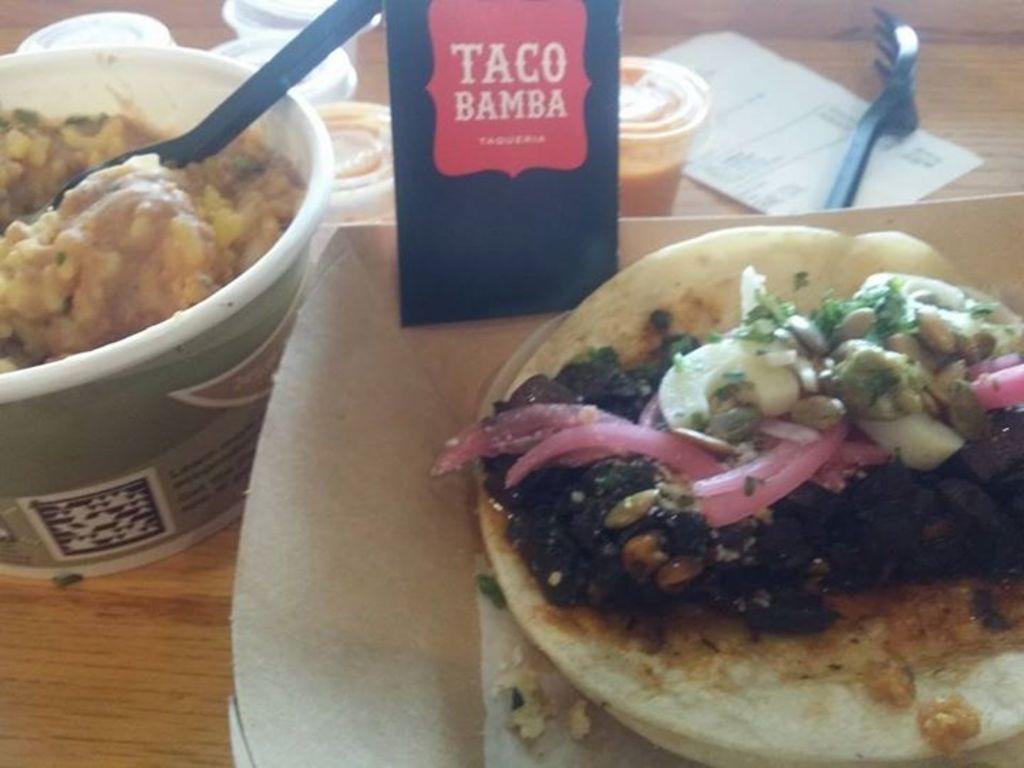What is the primary object in the image? There is a bowl in the image. What utensil is present in the image? There is a spoon in the image. What type of dishware can be seen in the image? There are cups in the image. What other utensil is present in the image? There is a fork in the image. What type of paper item is in the image? There is a paper in the image. What type of card is in the image? There is a card in the image. What type of food is present in the image? There is food in the image. On what surface are the objects placed? The objects are placed on a wooden platform. What type of farm animals can be seen in the image? There are no farm animals present in the image. What is the aftermath of the event depicted in the image? There is no event depicted in the image, so it's not possible to determine the aftermath. 